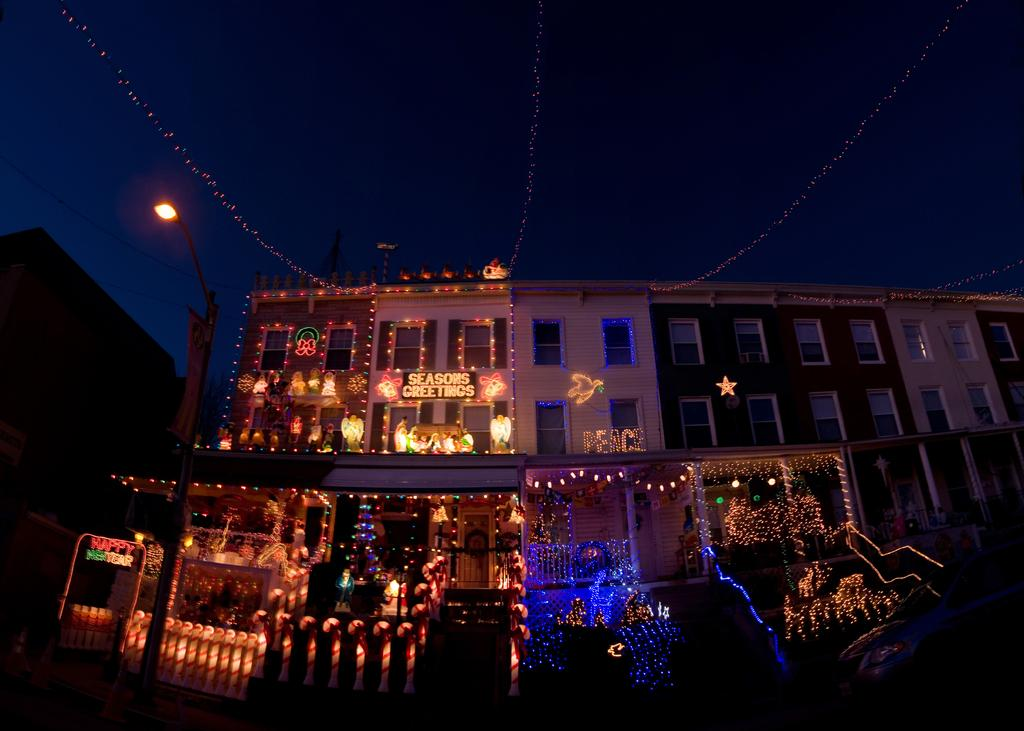What type of structure is visible in the image? There is a building in the image. What features can be observed on the building? The building has multiple windows and lights as decoration. What else can be seen in the image besides the building? There is a pole and a street light in the image. How would you describe the lighting conditions in the image? The image appears to be slightly dark. Can you see a hose spraying water near the building in the image? There is no hose or water spray visible in the image. Is there a faucet attached to the building for water access? There is no faucet present in the image. 